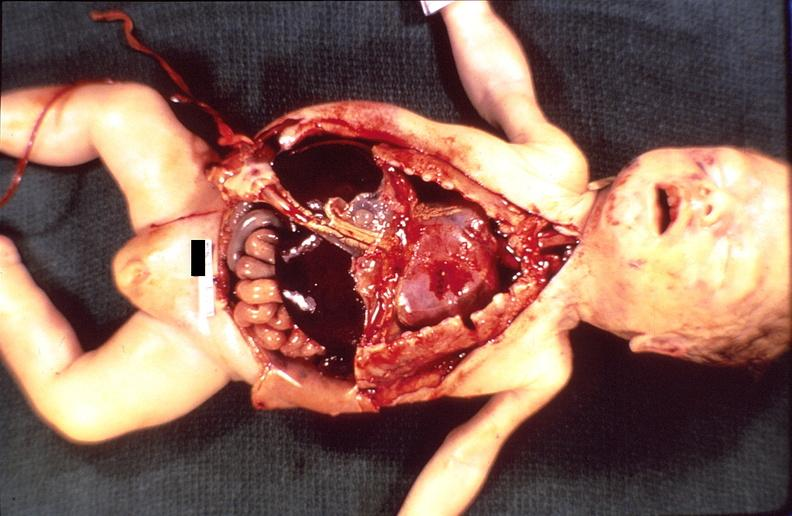what does this image show?
Answer the question using a single word or phrase. Hemolytic disease of newborn 